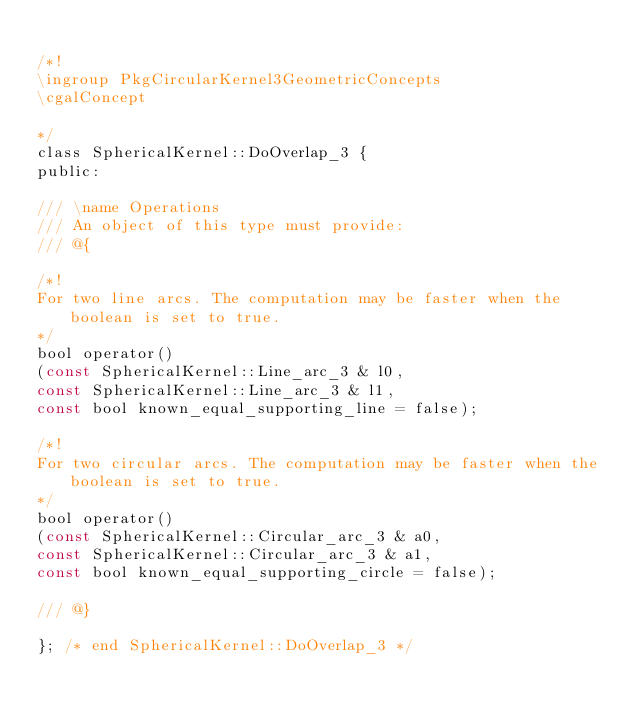Convert code to text. <code><loc_0><loc_0><loc_500><loc_500><_C_>
/*!
\ingroup PkgCircularKernel3GeometricConcepts
\cgalConcept

*/
class SphericalKernel::DoOverlap_3 {
public:

/// \name Operations
/// An object of this type must provide:
/// @{

/*!
For two line arcs. The computation may be faster when the boolean is set to true.
*/
bool operator()
(const SphericalKernel::Line_arc_3 & l0,
const SphericalKernel::Line_arc_3 & l1,
const bool known_equal_supporting_line = false);

/*!
For two circular arcs. The computation may be faster when the boolean is set to true.
*/
bool operator()
(const SphericalKernel::Circular_arc_3 & a0,
const SphericalKernel::Circular_arc_3 & a1,
const bool known_equal_supporting_circle = false);

/// @}

}; /* end SphericalKernel::DoOverlap_3 */

</code> 